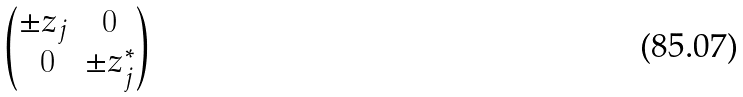<formula> <loc_0><loc_0><loc_500><loc_500>\begin{pmatrix} \pm z _ { j } & 0 \\ \ 0 & \pm z ^ { * } _ { j } \end{pmatrix}</formula> 